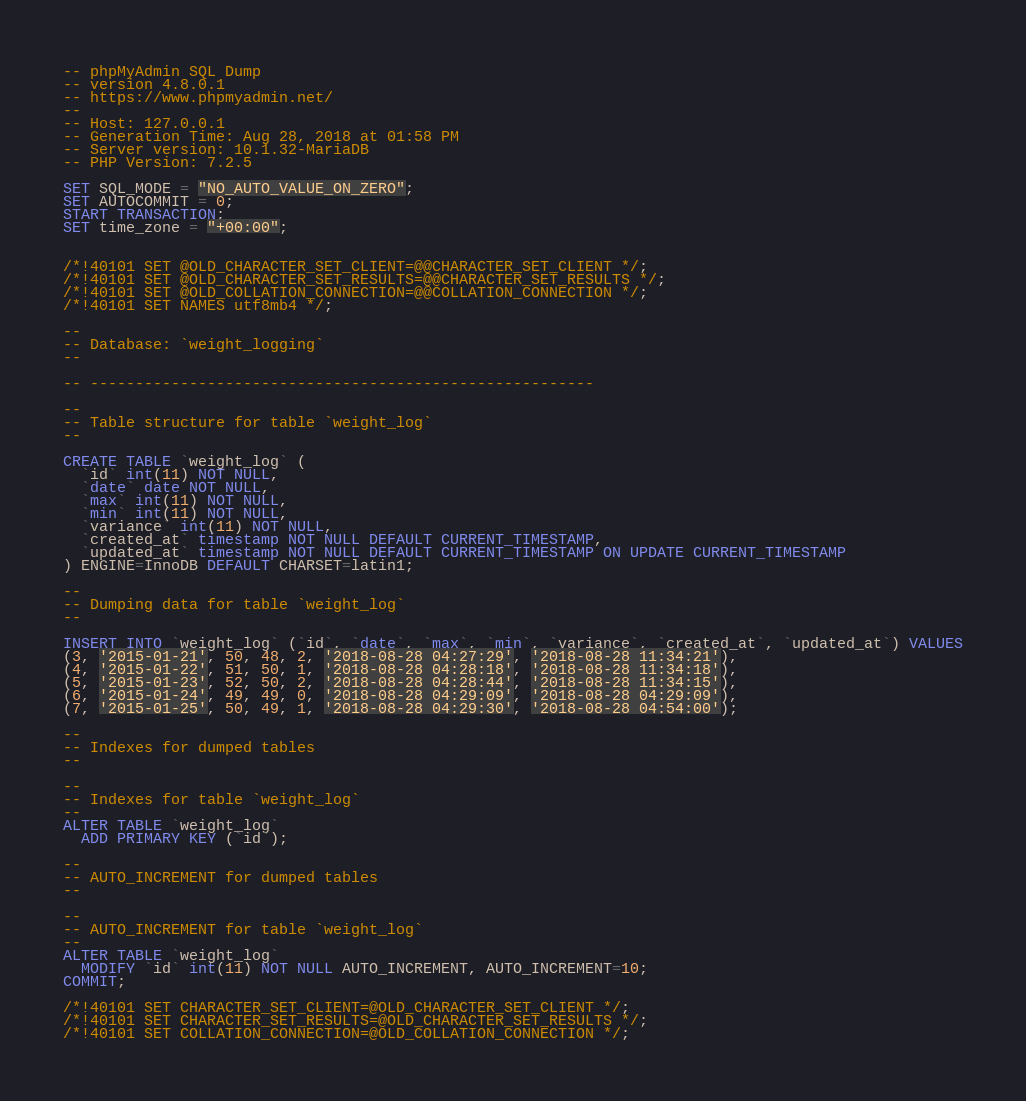Convert code to text. <code><loc_0><loc_0><loc_500><loc_500><_SQL_>-- phpMyAdmin SQL Dump
-- version 4.8.0.1
-- https://www.phpmyadmin.net/
--
-- Host: 127.0.0.1
-- Generation Time: Aug 28, 2018 at 01:58 PM
-- Server version: 10.1.32-MariaDB
-- PHP Version: 7.2.5

SET SQL_MODE = "NO_AUTO_VALUE_ON_ZERO";
SET AUTOCOMMIT = 0;
START TRANSACTION;
SET time_zone = "+00:00";


/*!40101 SET @OLD_CHARACTER_SET_CLIENT=@@CHARACTER_SET_CLIENT */;
/*!40101 SET @OLD_CHARACTER_SET_RESULTS=@@CHARACTER_SET_RESULTS */;
/*!40101 SET @OLD_COLLATION_CONNECTION=@@COLLATION_CONNECTION */;
/*!40101 SET NAMES utf8mb4 */;

--
-- Database: `weight_logging`
--

-- --------------------------------------------------------

--
-- Table structure for table `weight_log`
--

CREATE TABLE `weight_log` (
  `id` int(11) NOT NULL,
  `date` date NOT NULL,
  `max` int(11) NOT NULL,
  `min` int(11) NOT NULL,
  `variance` int(11) NOT NULL,
  `created_at` timestamp NOT NULL DEFAULT CURRENT_TIMESTAMP,
  `updated_at` timestamp NOT NULL DEFAULT CURRENT_TIMESTAMP ON UPDATE CURRENT_TIMESTAMP
) ENGINE=InnoDB DEFAULT CHARSET=latin1;

--
-- Dumping data for table `weight_log`
--

INSERT INTO `weight_log` (`id`, `date`, `max`, `min`, `variance`, `created_at`, `updated_at`) VALUES
(3, '2015-01-21', 50, 48, 2, '2018-08-28 04:27:29', '2018-08-28 11:34:21'),
(4, '2015-01-22', 51, 50, 1, '2018-08-28 04:28:18', '2018-08-28 11:34:18'),
(5, '2015-01-23', 52, 50, 2, '2018-08-28 04:28:44', '2018-08-28 11:34:15'),
(6, '2015-01-24', 49, 49, 0, '2018-08-28 04:29:09', '2018-08-28 04:29:09'),
(7, '2015-01-25', 50, 49, 1, '2018-08-28 04:29:30', '2018-08-28 04:54:00');

--
-- Indexes for dumped tables
--

--
-- Indexes for table `weight_log`
--
ALTER TABLE `weight_log`
  ADD PRIMARY KEY (`id`);

--
-- AUTO_INCREMENT for dumped tables
--

--
-- AUTO_INCREMENT for table `weight_log`
--
ALTER TABLE `weight_log`
  MODIFY `id` int(11) NOT NULL AUTO_INCREMENT, AUTO_INCREMENT=10;
COMMIT;

/*!40101 SET CHARACTER_SET_CLIENT=@OLD_CHARACTER_SET_CLIENT */;
/*!40101 SET CHARACTER_SET_RESULTS=@OLD_CHARACTER_SET_RESULTS */;
/*!40101 SET COLLATION_CONNECTION=@OLD_COLLATION_CONNECTION */;
</code> 